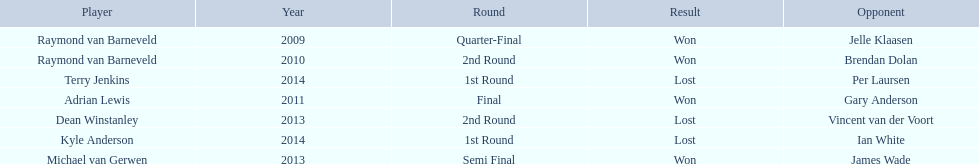Who are all the players? Raymond van Barneveld, Raymond van Barneveld, Adrian Lewis, Dean Winstanley, Michael van Gerwen, Terry Jenkins, Kyle Anderson. When did they play? 2009, 2010, 2011, 2013, 2013, 2014, 2014. And which player played in 2011? Adrian Lewis. 